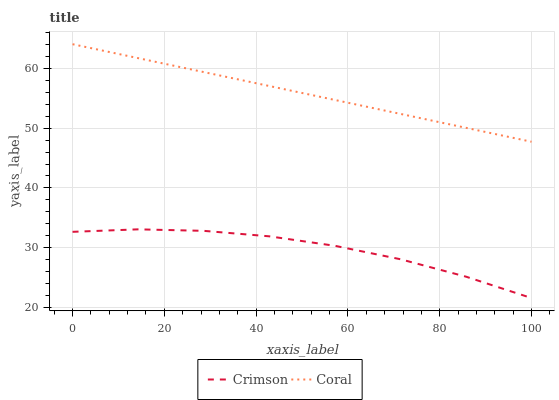Does Crimson have the minimum area under the curve?
Answer yes or no. Yes. Does Coral have the maximum area under the curve?
Answer yes or no. Yes. Does Coral have the minimum area under the curve?
Answer yes or no. No. Is Coral the smoothest?
Answer yes or no. Yes. Is Crimson the roughest?
Answer yes or no. Yes. Is Coral the roughest?
Answer yes or no. No. Does Crimson have the lowest value?
Answer yes or no. Yes. Does Coral have the lowest value?
Answer yes or no. No. Does Coral have the highest value?
Answer yes or no. Yes. Is Crimson less than Coral?
Answer yes or no. Yes. Is Coral greater than Crimson?
Answer yes or no. Yes. Does Crimson intersect Coral?
Answer yes or no. No. 